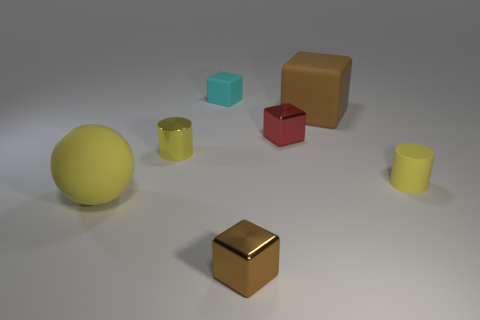How many objects are either matte objects that are behind the red block or large rubber things on the left side of the tiny brown shiny block?
Make the answer very short. 3. Is the matte cylinder the same size as the brown matte cube?
Keep it short and to the point. No. There is a small rubber object behind the tiny red object; is its shape the same as the tiny shiny object behind the yellow metal thing?
Ensure brevity in your answer.  Yes. What size is the yellow shiny thing?
Keep it short and to the point. Small. The large object that is right of the tiny metal cube that is to the right of the cube that is in front of the big yellow matte thing is made of what material?
Offer a very short reply. Rubber. How many other things are the same color as the large cube?
Make the answer very short. 1. How many purple objects are either tiny cylinders or tiny rubber cubes?
Provide a short and direct response. 0. There is a brown object that is behind the tiny brown thing; what material is it?
Keep it short and to the point. Rubber. Is the material of the tiny yellow cylinder that is right of the tiny rubber cube the same as the tiny red block?
Keep it short and to the point. No. What shape is the brown rubber object?
Provide a short and direct response. Cube. 